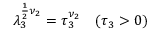<formula> <loc_0><loc_0><loc_500><loc_500>\lambda _ { 3 } ^ { \frac { 1 } { 2 } \nu _ { 2 } } = \tau _ { 3 } ^ { \nu _ { 2 } } \quad ( \tau _ { 3 } > 0 )</formula> 